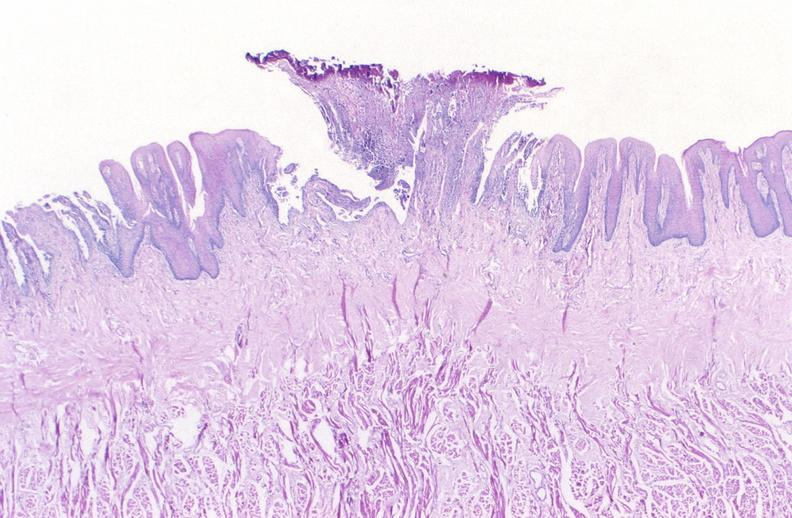s atheromatous embolus present?
Answer the question using a single word or phrase. No 